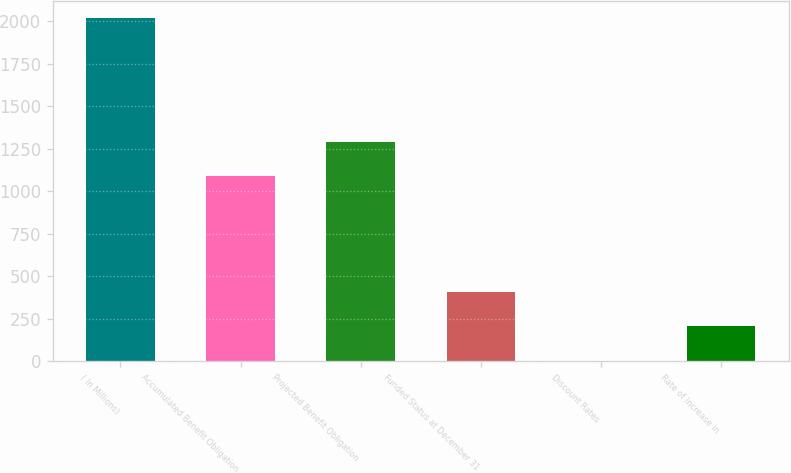<chart> <loc_0><loc_0><loc_500><loc_500><bar_chart><fcel>( In Millions)<fcel>Accumulated Benefit Obligation<fcel>Projected Benefit Obligation<fcel>Funded Status at December 31<fcel>Discount Rates<fcel>Rate of Increase in<nl><fcel>2017<fcel>1088.4<fcel>1289.72<fcel>406.43<fcel>3.79<fcel>205.11<nl></chart> 